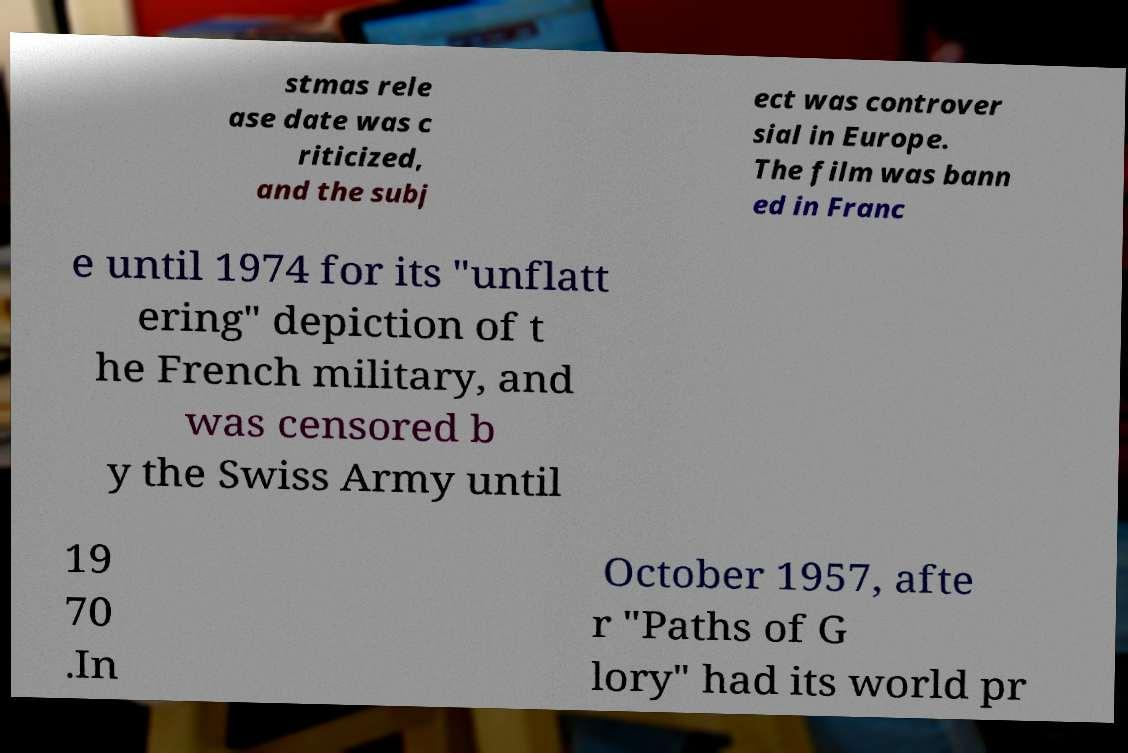What messages or text are displayed in this image? I need them in a readable, typed format. stmas rele ase date was c riticized, and the subj ect was controver sial in Europe. The film was bann ed in Franc e until 1974 for its "unflatt ering" depiction of t he French military, and was censored b y the Swiss Army until 19 70 .In October 1957, afte r "Paths of G lory" had its world pr 